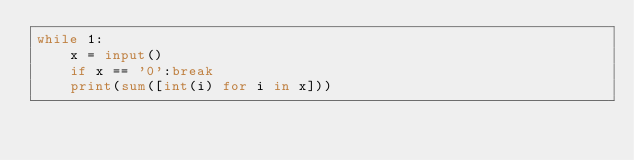Convert code to text. <code><loc_0><loc_0><loc_500><loc_500><_Python_>while 1:
    x = input()
    if x == '0':break
    print(sum([int(i) for i in x]))
</code> 